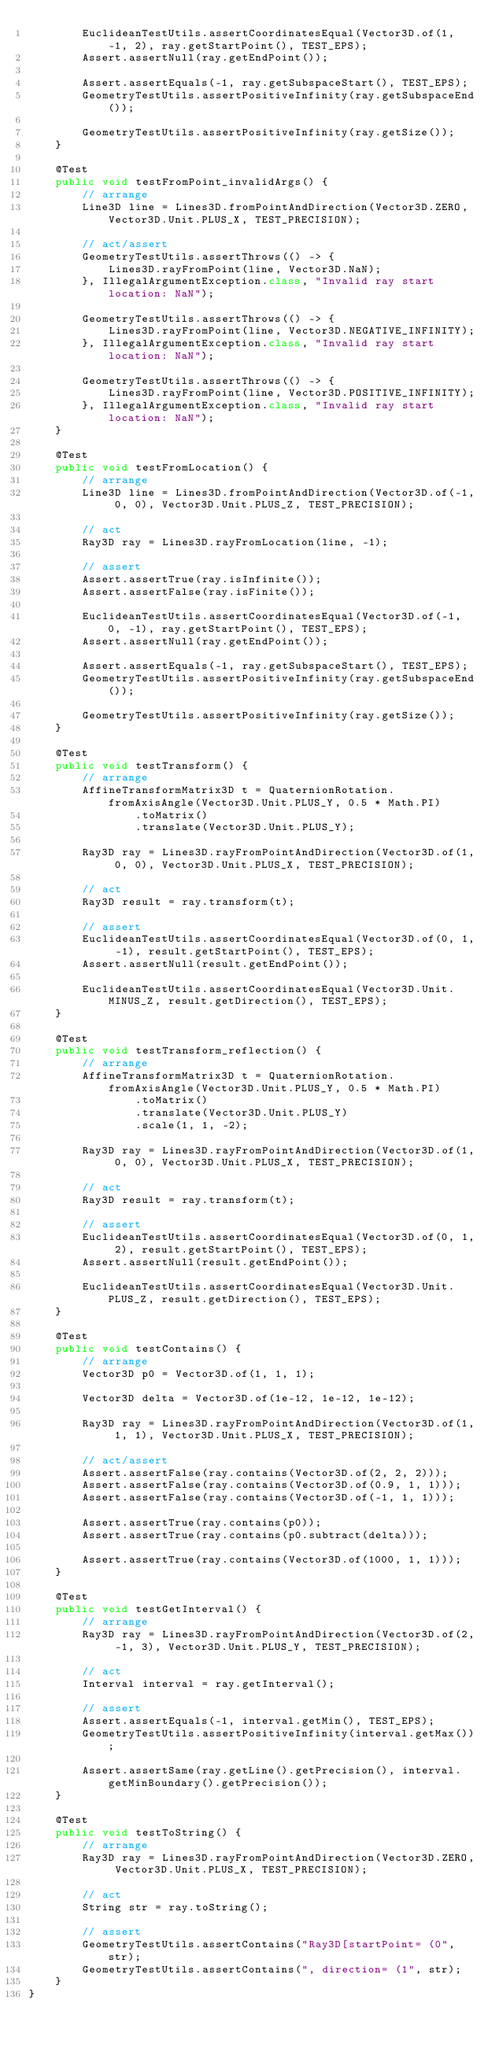<code> <loc_0><loc_0><loc_500><loc_500><_Java_>        EuclideanTestUtils.assertCoordinatesEqual(Vector3D.of(1, -1, 2), ray.getStartPoint(), TEST_EPS);
        Assert.assertNull(ray.getEndPoint());

        Assert.assertEquals(-1, ray.getSubspaceStart(), TEST_EPS);
        GeometryTestUtils.assertPositiveInfinity(ray.getSubspaceEnd());

        GeometryTestUtils.assertPositiveInfinity(ray.getSize());
    }

    @Test
    public void testFromPoint_invalidArgs() {
        // arrange
        Line3D line = Lines3D.fromPointAndDirection(Vector3D.ZERO, Vector3D.Unit.PLUS_X, TEST_PRECISION);

        // act/assert
        GeometryTestUtils.assertThrows(() -> {
            Lines3D.rayFromPoint(line, Vector3D.NaN);
        }, IllegalArgumentException.class, "Invalid ray start location: NaN");

        GeometryTestUtils.assertThrows(() -> {
            Lines3D.rayFromPoint(line, Vector3D.NEGATIVE_INFINITY);
        }, IllegalArgumentException.class, "Invalid ray start location: NaN");

        GeometryTestUtils.assertThrows(() -> {
            Lines3D.rayFromPoint(line, Vector3D.POSITIVE_INFINITY);
        }, IllegalArgumentException.class, "Invalid ray start location: NaN");
    }

    @Test
    public void testFromLocation() {
        // arrange
        Line3D line = Lines3D.fromPointAndDirection(Vector3D.of(-1, 0, 0), Vector3D.Unit.PLUS_Z, TEST_PRECISION);

        // act
        Ray3D ray = Lines3D.rayFromLocation(line, -1);

        // assert
        Assert.assertTrue(ray.isInfinite());
        Assert.assertFalse(ray.isFinite());

        EuclideanTestUtils.assertCoordinatesEqual(Vector3D.of(-1, 0, -1), ray.getStartPoint(), TEST_EPS);
        Assert.assertNull(ray.getEndPoint());

        Assert.assertEquals(-1, ray.getSubspaceStart(), TEST_EPS);
        GeometryTestUtils.assertPositiveInfinity(ray.getSubspaceEnd());

        GeometryTestUtils.assertPositiveInfinity(ray.getSize());
    }

    @Test
    public void testTransform() {
        // arrange
        AffineTransformMatrix3D t = QuaternionRotation.fromAxisAngle(Vector3D.Unit.PLUS_Y, 0.5 * Math.PI)
                .toMatrix()
                .translate(Vector3D.Unit.PLUS_Y);

        Ray3D ray = Lines3D.rayFromPointAndDirection(Vector3D.of(1, 0, 0), Vector3D.Unit.PLUS_X, TEST_PRECISION);

        // act
        Ray3D result = ray.transform(t);

        // assert
        EuclideanTestUtils.assertCoordinatesEqual(Vector3D.of(0, 1, -1), result.getStartPoint(), TEST_EPS);
        Assert.assertNull(result.getEndPoint());

        EuclideanTestUtils.assertCoordinatesEqual(Vector3D.Unit.MINUS_Z, result.getDirection(), TEST_EPS);
    }

    @Test
    public void testTransform_reflection() {
        // arrange
        AffineTransformMatrix3D t = QuaternionRotation.fromAxisAngle(Vector3D.Unit.PLUS_Y, 0.5 * Math.PI)
                .toMatrix()
                .translate(Vector3D.Unit.PLUS_Y)
                .scale(1, 1, -2);

        Ray3D ray = Lines3D.rayFromPointAndDirection(Vector3D.of(1, 0, 0), Vector3D.Unit.PLUS_X, TEST_PRECISION);

        // act
        Ray3D result = ray.transform(t);

        // assert
        EuclideanTestUtils.assertCoordinatesEqual(Vector3D.of(0, 1, 2), result.getStartPoint(), TEST_EPS);
        Assert.assertNull(result.getEndPoint());

        EuclideanTestUtils.assertCoordinatesEqual(Vector3D.Unit.PLUS_Z, result.getDirection(), TEST_EPS);
    }

    @Test
    public void testContains() {
        // arrange
        Vector3D p0 = Vector3D.of(1, 1, 1);

        Vector3D delta = Vector3D.of(1e-12, 1e-12, 1e-12);

        Ray3D ray = Lines3D.rayFromPointAndDirection(Vector3D.of(1, 1, 1), Vector3D.Unit.PLUS_X, TEST_PRECISION);

        // act/assert
        Assert.assertFalse(ray.contains(Vector3D.of(2, 2, 2)));
        Assert.assertFalse(ray.contains(Vector3D.of(0.9, 1, 1)));
        Assert.assertFalse(ray.contains(Vector3D.of(-1, 1, 1)));

        Assert.assertTrue(ray.contains(p0));
        Assert.assertTrue(ray.contains(p0.subtract(delta)));

        Assert.assertTrue(ray.contains(Vector3D.of(1000, 1, 1)));
    }

    @Test
    public void testGetInterval() {
        // arrange
        Ray3D ray = Lines3D.rayFromPointAndDirection(Vector3D.of(2, -1, 3), Vector3D.Unit.PLUS_Y, TEST_PRECISION);

        // act
        Interval interval = ray.getInterval();

        // assert
        Assert.assertEquals(-1, interval.getMin(), TEST_EPS);
        GeometryTestUtils.assertPositiveInfinity(interval.getMax());

        Assert.assertSame(ray.getLine().getPrecision(), interval.getMinBoundary().getPrecision());
    }

    @Test
    public void testToString() {
        // arrange
        Ray3D ray = Lines3D.rayFromPointAndDirection(Vector3D.ZERO, Vector3D.Unit.PLUS_X, TEST_PRECISION);

        // act
        String str = ray.toString();

        // assert
        GeometryTestUtils.assertContains("Ray3D[startPoint= (0", str);
        GeometryTestUtils.assertContains(", direction= (1", str);
    }
}
</code> 